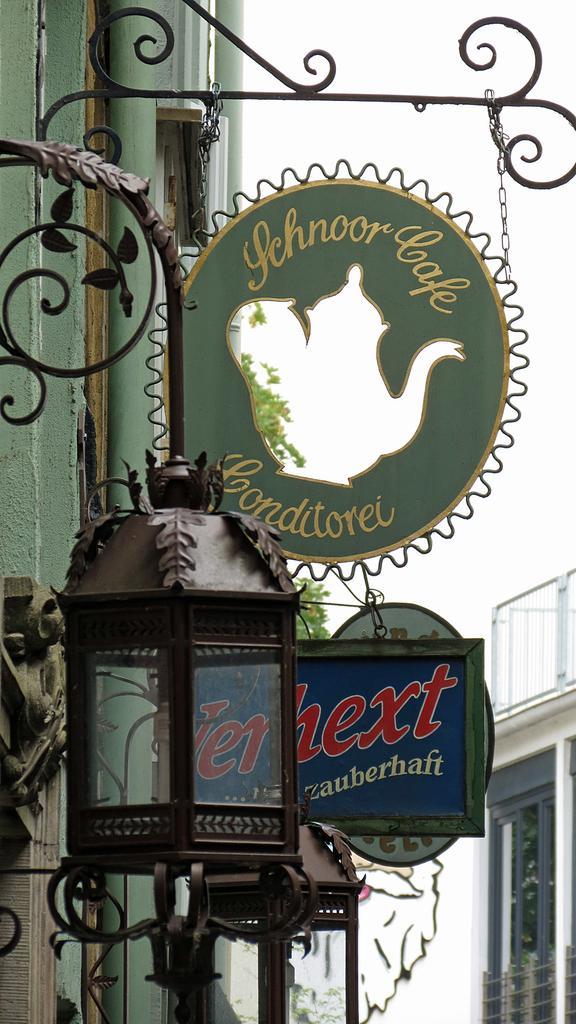Please provide a concise description of this image. In this picture we can see some lanterns and few boards on the pole. There is a building on the left side and on the right side. 